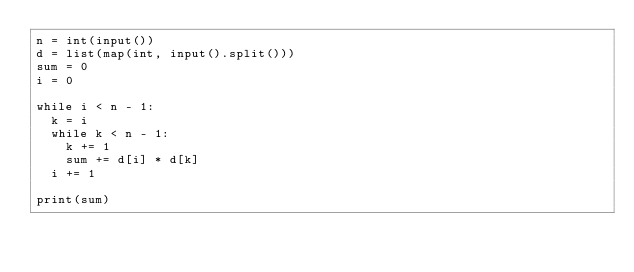<code> <loc_0><loc_0><loc_500><loc_500><_Python_>n = int(input())
d = list(map(int, input().split()))
sum = 0
i = 0

while i < n - 1:
  k = i
  while k < n - 1:
    k += 1
    sum += d[i] * d[k]
  i += 1
  
print(sum)

</code> 